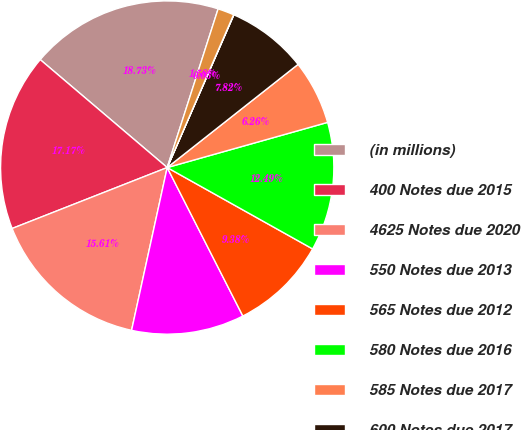<chart> <loc_0><loc_0><loc_500><loc_500><pie_chart><fcel>(in millions)<fcel>400 Notes due 2015<fcel>4625 Notes due 2020<fcel>550 Notes due 2013<fcel>565 Notes due 2012<fcel>580 Notes due 2016<fcel>585 Notes due 2017<fcel>600 Notes due 2017<fcel>675 Notes due 2011<fcel>780 Debentures due 2016<nl><fcel>18.73%<fcel>17.17%<fcel>15.61%<fcel>10.93%<fcel>9.38%<fcel>12.49%<fcel>6.26%<fcel>7.82%<fcel>0.03%<fcel>1.58%<nl></chart> 